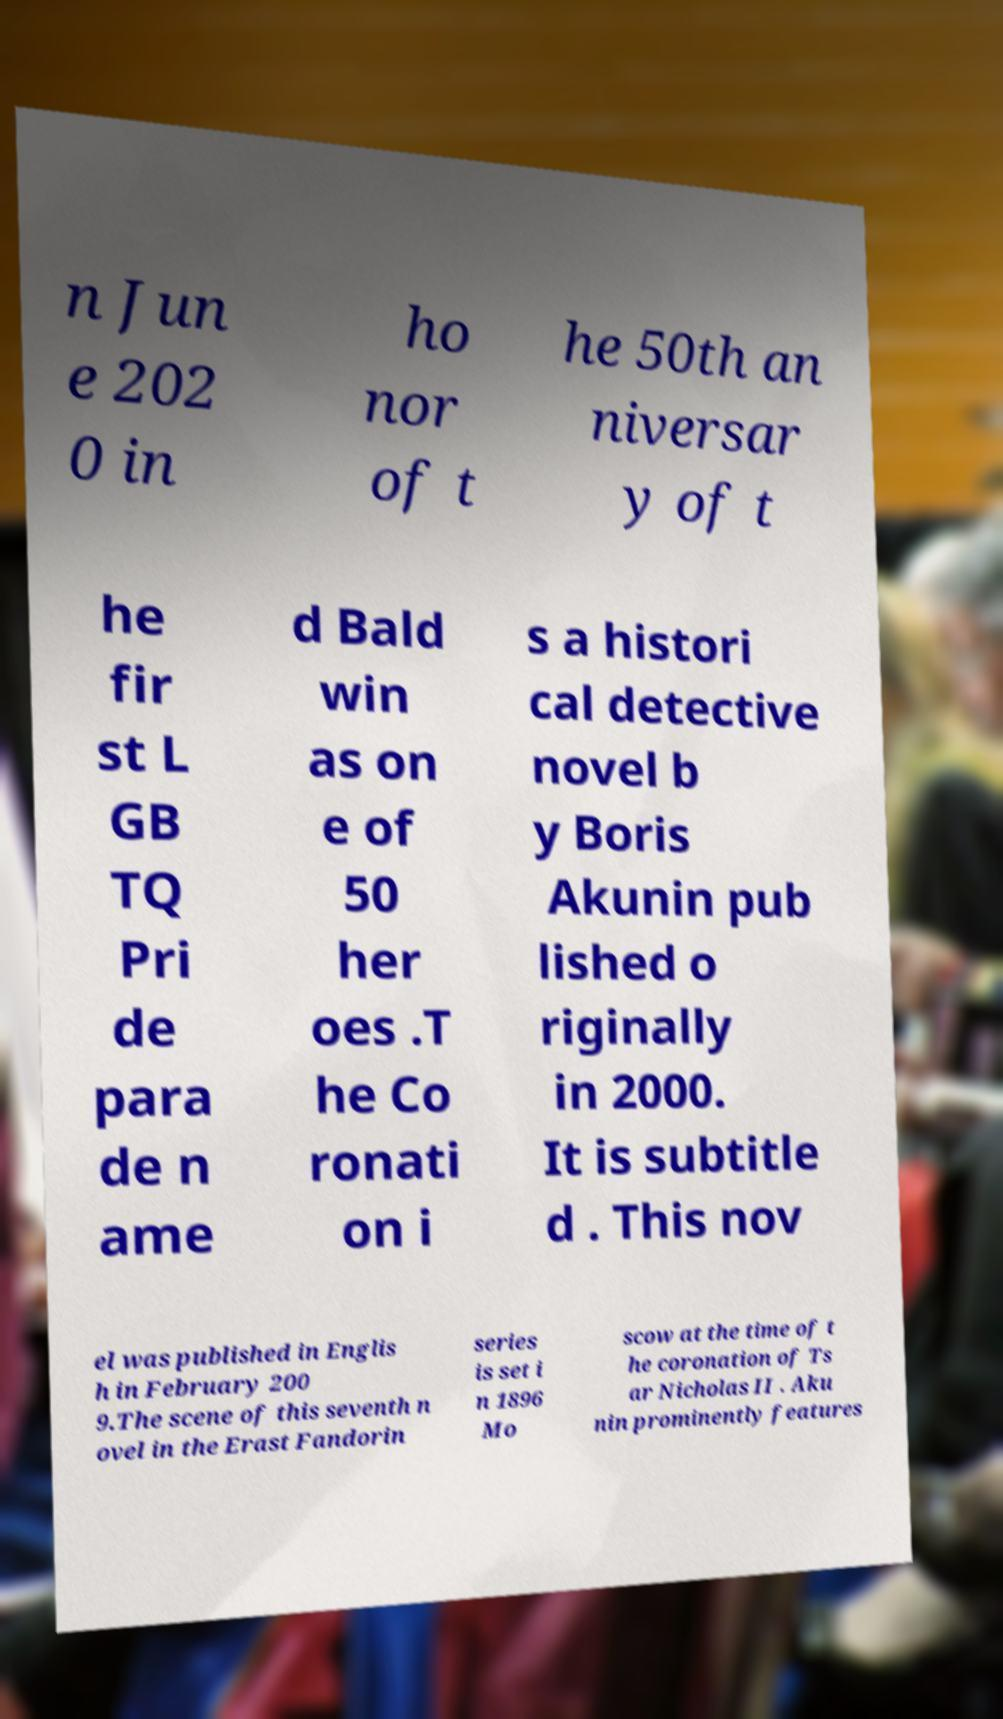What messages or text are displayed in this image? I need them in a readable, typed format. n Jun e 202 0 in ho nor of t he 50th an niversar y of t he fir st L GB TQ Pri de para de n ame d Bald win as on e of 50 her oes .T he Co ronati on i s a histori cal detective novel b y Boris Akunin pub lished o riginally in 2000. It is subtitle d . This nov el was published in Englis h in February 200 9.The scene of this seventh n ovel in the Erast Fandorin series is set i n 1896 Mo scow at the time of t he coronation of Ts ar Nicholas II . Aku nin prominently features 